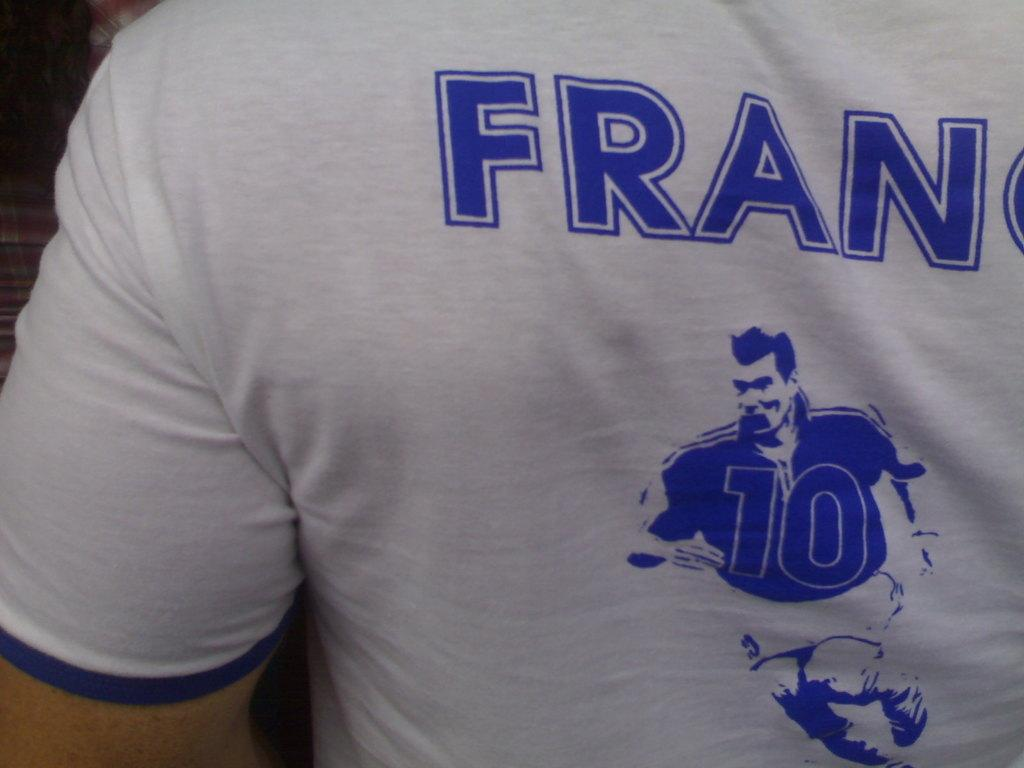<image>
Relay a brief, clear account of the picture shown. a close up of a white t shirt with words Fran on it 